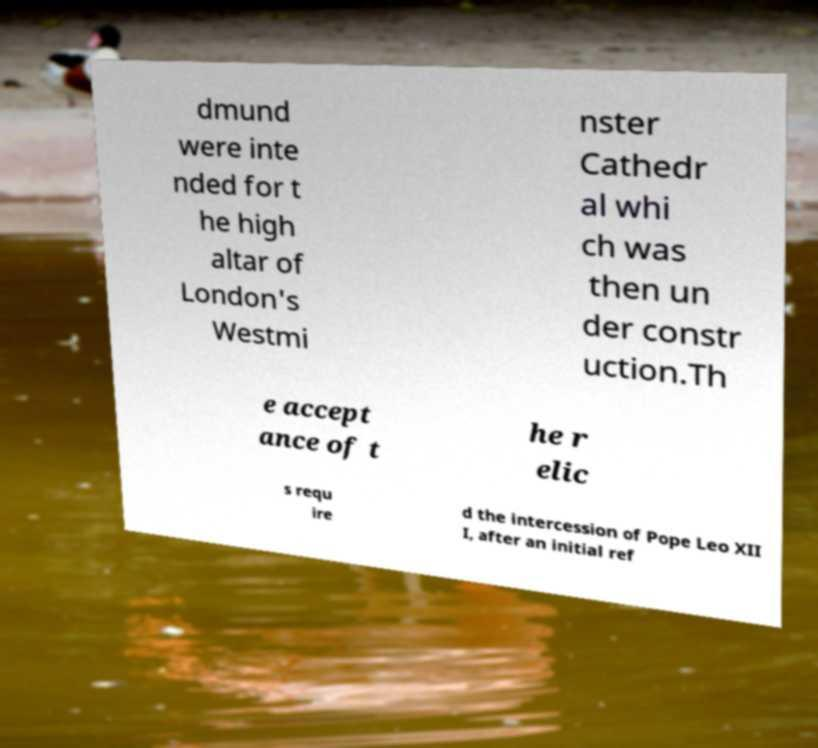Could you assist in decoding the text presented in this image and type it out clearly? dmund were inte nded for t he high altar of London's Westmi nster Cathedr al whi ch was then un der constr uction.Th e accept ance of t he r elic s requ ire d the intercession of Pope Leo XII I, after an initial ref 